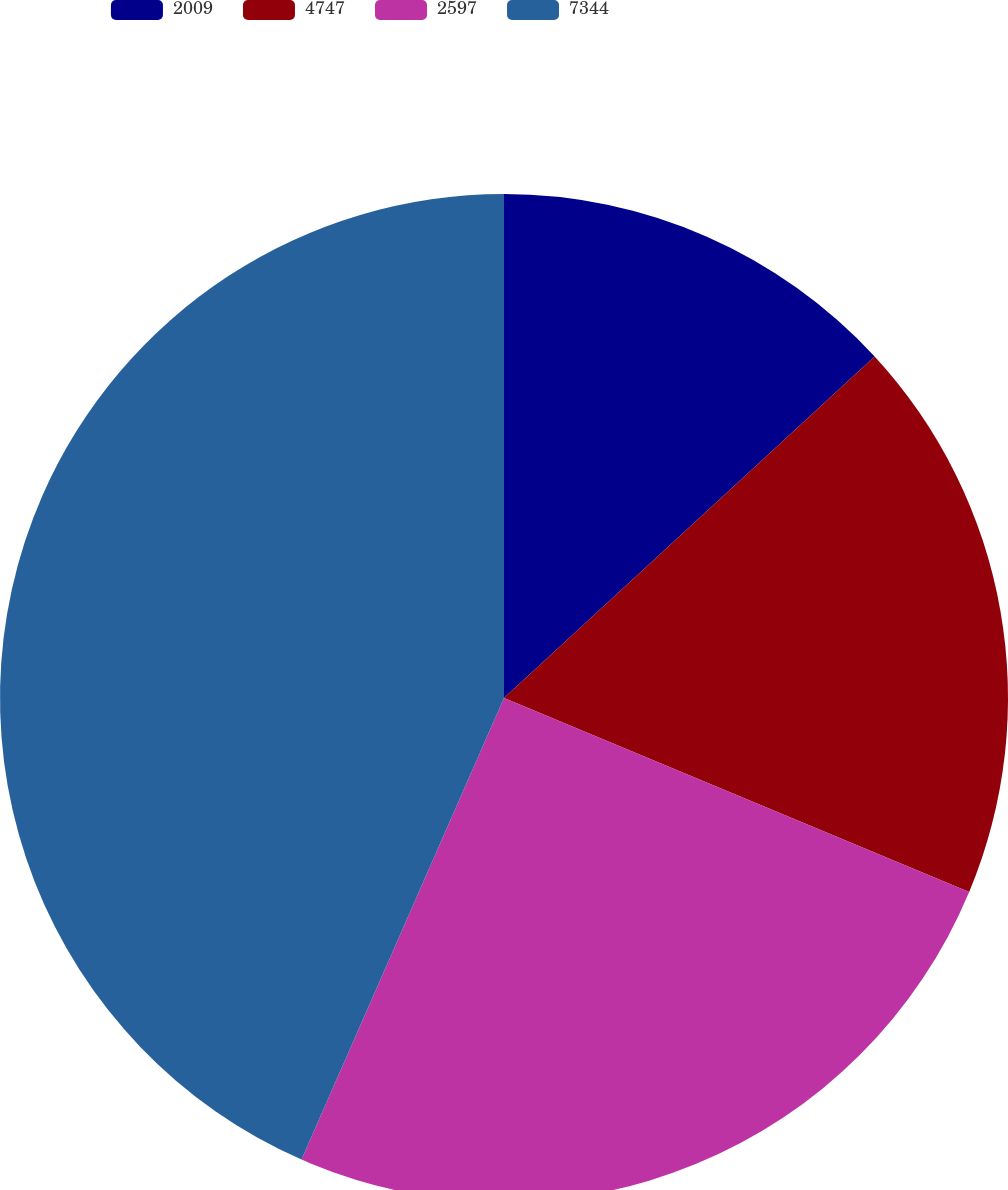Convert chart to OTSL. <chart><loc_0><loc_0><loc_500><loc_500><pie_chart><fcel>2009<fcel>4747<fcel>2597<fcel>7344<nl><fcel>13.15%<fcel>18.14%<fcel>25.29%<fcel>43.42%<nl></chart> 